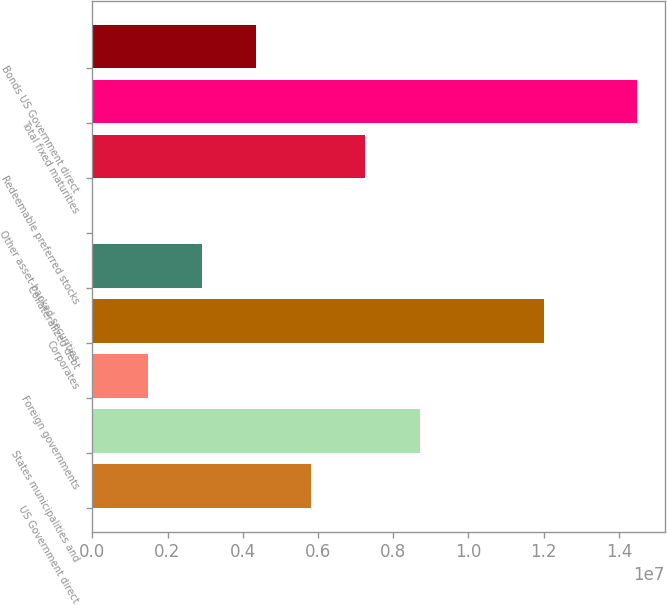Convert chart to OTSL. <chart><loc_0><loc_0><loc_500><loc_500><bar_chart><fcel>US Government direct<fcel>States municipalities and<fcel>Foreign governments<fcel>Corporates<fcel>Collateralized debt<fcel>Other asset-backed securities<fcel>Redeemable preferred stocks<fcel>Total fixed maturities<fcel>Bonds US Government direct<nl><fcel>5.81074e+06<fcel>8.70485e+06<fcel>1.46958e+06<fcel>1.2006e+07<fcel>2.91663e+06<fcel>22528<fcel>7.25779e+06<fcel>1.44931e+07<fcel>4.36369e+06<nl></chart> 